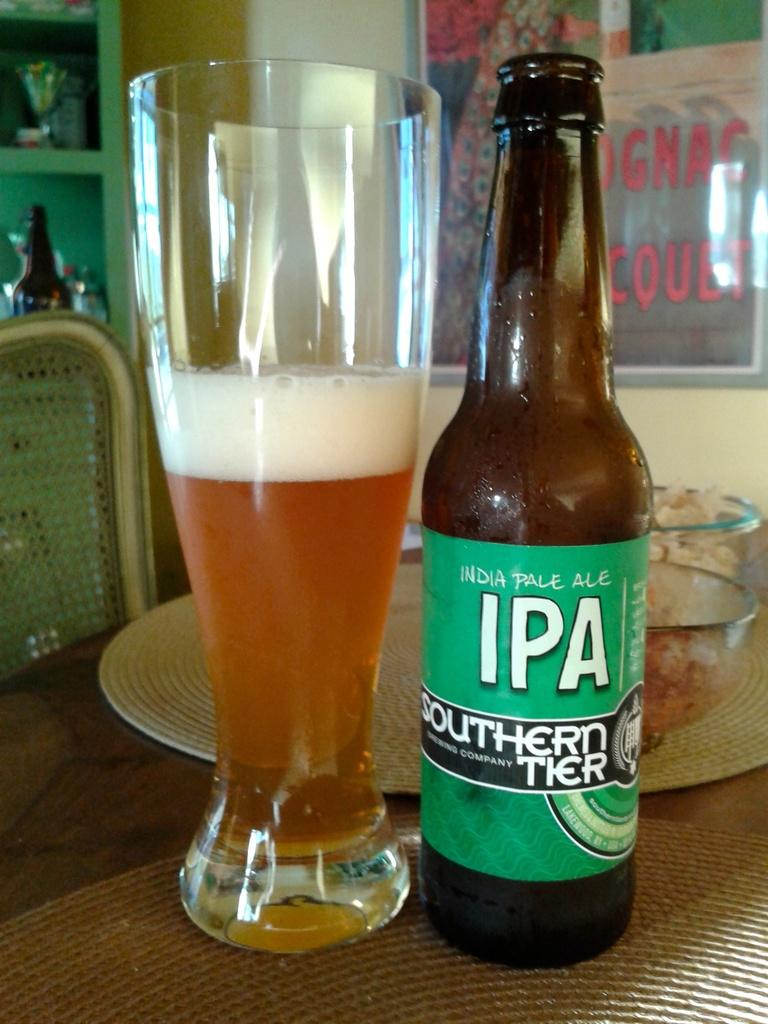Provide a one-sentence caption for the provided image. bottle of india pale ale IPA southern tier next to a half full glass. 